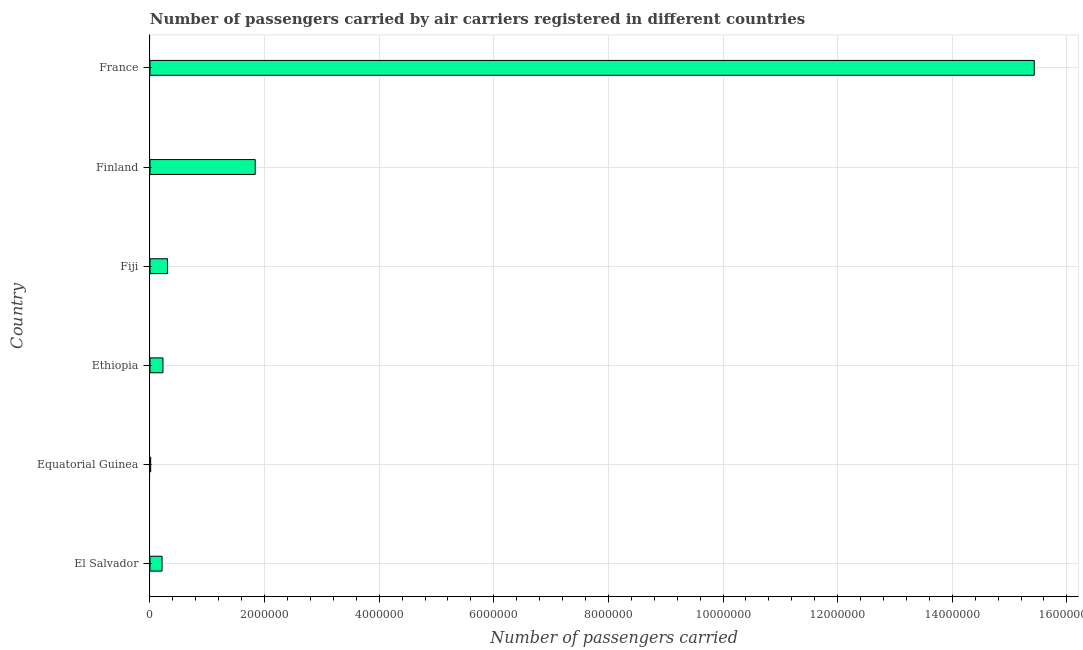Does the graph contain any zero values?
Keep it short and to the point. No. Does the graph contain grids?
Make the answer very short. Yes. What is the title of the graph?
Ensure brevity in your answer.  Number of passengers carried by air carriers registered in different countries. What is the label or title of the X-axis?
Offer a very short reply. Number of passengers carried. What is the number of passengers carried in Ethiopia?
Your answer should be very brief. 2.26e+05. Across all countries, what is the maximum number of passengers carried?
Ensure brevity in your answer.  1.54e+07. Across all countries, what is the minimum number of passengers carried?
Provide a short and direct response. 1.20e+04. In which country was the number of passengers carried maximum?
Keep it short and to the point. France. In which country was the number of passengers carried minimum?
Make the answer very short. Equatorial Guinea. What is the sum of the number of passengers carried?
Your answer should be very brief. 1.80e+07. What is the difference between the number of passengers carried in Finland and France?
Provide a succinct answer. -1.36e+07. What is the average number of passengers carried per country?
Provide a succinct answer. 3.00e+06. What is the median number of passengers carried?
Keep it short and to the point. 2.66e+05. Is the number of passengers carried in Equatorial Guinea less than that in France?
Offer a very short reply. Yes. Is the difference between the number of passengers carried in Ethiopia and Fiji greater than the difference between any two countries?
Your response must be concise. No. What is the difference between the highest and the second highest number of passengers carried?
Provide a succinct answer. 1.36e+07. What is the difference between the highest and the lowest number of passengers carried?
Your response must be concise. 1.54e+07. In how many countries, is the number of passengers carried greater than the average number of passengers carried taken over all countries?
Your response must be concise. 1. What is the difference between two consecutive major ticks on the X-axis?
Your answer should be compact. 2.00e+06. Are the values on the major ticks of X-axis written in scientific E-notation?
Provide a succinct answer. No. What is the Number of passengers carried in El Salvador?
Provide a succinct answer. 2.11e+05. What is the Number of passengers carried of Equatorial Guinea?
Offer a very short reply. 1.20e+04. What is the Number of passengers carried in Ethiopia?
Offer a very short reply. 2.26e+05. What is the Number of passengers carried in Fiji?
Your answer should be compact. 3.05e+05. What is the Number of passengers carried of Finland?
Your answer should be very brief. 1.84e+06. What is the Number of passengers carried in France?
Your response must be concise. 1.54e+07. What is the difference between the Number of passengers carried in El Salvador and Equatorial Guinea?
Provide a succinct answer. 1.99e+05. What is the difference between the Number of passengers carried in El Salvador and Ethiopia?
Your answer should be very brief. -1.55e+04. What is the difference between the Number of passengers carried in El Salvador and Fiji?
Offer a terse response. -9.44e+04. What is the difference between the Number of passengers carried in El Salvador and Finland?
Keep it short and to the point. -1.63e+06. What is the difference between the Number of passengers carried in El Salvador and France?
Give a very brief answer. -1.52e+07. What is the difference between the Number of passengers carried in Equatorial Guinea and Ethiopia?
Provide a succinct answer. -2.14e+05. What is the difference between the Number of passengers carried in Equatorial Guinea and Fiji?
Your answer should be compact. -2.93e+05. What is the difference between the Number of passengers carried in Equatorial Guinea and Finland?
Make the answer very short. -1.82e+06. What is the difference between the Number of passengers carried in Equatorial Guinea and France?
Your answer should be compact. -1.54e+07. What is the difference between the Number of passengers carried in Ethiopia and Fiji?
Provide a short and direct response. -7.89e+04. What is the difference between the Number of passengers carried in Ethiopia and Finland?
Give a very brief answer. -1.61e+06. What is the difference between the Number of passengers carried in Ethiopia and France?
Make the answer very short. -1.52e+07. What is the difference between the Number of passengers carried in Fiji and Finland?
Your response must be concise. -1.53e+06. What is the difference between the Number of passengers carried in Fiji and France?
Make the answer very short. -1.51e+07. What is the difference between the Number of passengers carried in Finland and France?
Give a very brief answer. -1.36e+07. What is the ratio of the Number of passengers carried in El Salvador to that in Equatorial Guinea?
Your response must be concise. 17.55. What is the ratio of the Number of passengers carried in El Salvador to that in Ethiopia?
Provide a short and direct response. 0.93. What is the ratio of the Number of passengers carried in El Salvador to that in Fiji?
Make the answer very short. 0.69. What is the ratio of the Number of passengers carried in El Salvador to that in Finland?
Keep it short and to the point. 0.12. What is the ratio of the Number of passengers carried in El Salvador to that in France?
Make the answer very short. 0.01. What is the ratio of the Number of passengers carried in Equatorial Guinea to that in Ethiopia?
Offer a terse response. 0.05. What is the ratio of the Number of passengers carried in Equatorial Guinea to that in Fiji?
Give a very brief answer. 0.04. What is the ratio of the Number of passengers carried in Equatorial Guinea to that in Finland?
Provide a succinct answer. 0.01. What is the ratio of the Number of passengers carried in Equatorial Guinea to that in France?
Your answer should be very brief. 0. What is the ratio of the Number of passengers carried in Ethiopia to that in Fiji?
Give a very brief answer. 0.74. What is the ratio of the Number of passengers carried in Ethiopia to that in Finland?
Your answer should be very brief. 0.12. What is the ratio of the Number of passengers carried in Ethiopia to that in France?
Offer a terse response. 0.01. What is the ratio of the Number of passengers carried in Fiji to that in Finland?
Provide a succinct answer. 0.17. What is the ratio of the Number of passengers carried in Finland to that in France?
Your response must be concise. 0.12. 